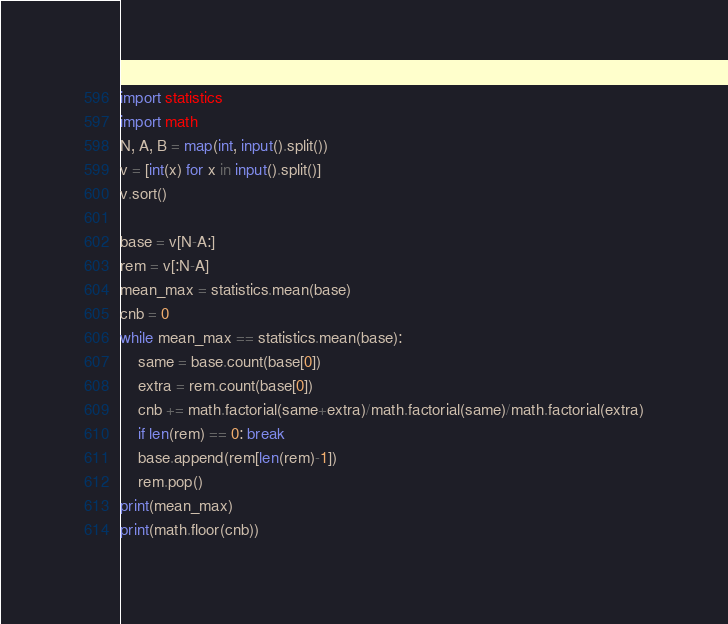Convert code to text. <code><loc_0><loc_0><loc_500><loc_500><_Python_>import statistics
import math
N, A, B = map(int, input().split())
v = [int(x) for x in input().split()]
v.sort()

base = v[N-A:]
rem = v[:N-A]
mean_max = statistics.mean(base)
cnb = 0
while mean_max == statistics.mean(base):
    same = base.count(base[0])
    extra = rem.count(base[0])
    cnb += math.factorial(same+extra)/math.factorial(same)/math.factorial(extra)
    if len(rem) == 0: break
    base.append(rem[len(rem)-1])
    rem.pop()
print(mean_max)
print(math.floor(cnb))</code> 